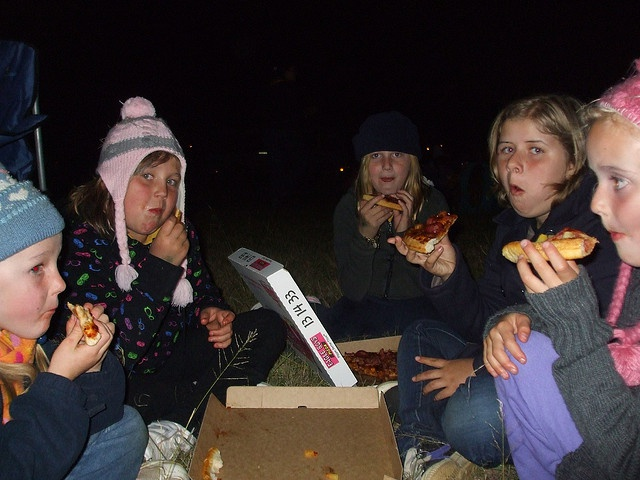Describe the objects in this image and their specific colors. I can see people in black, brown, darkgray, and gray tones, people in black, gray, and lightpink tones, people in black, gray, and maroon tones, people in black, tan, blue, and gray tones, and people in black, maroon, and brown tones in this image. 